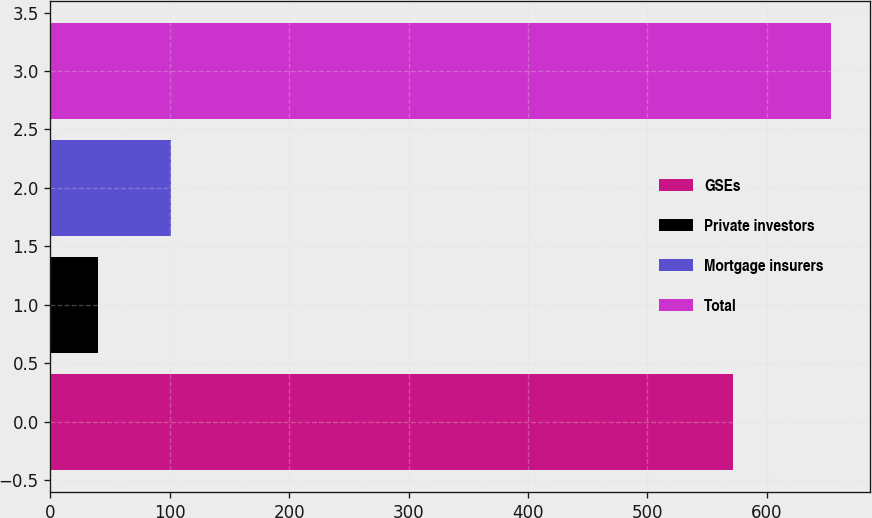<chart> <loc_0><loc_0><loc_500><loc_500><bar_chart><fcel>GSEs<fcel>Private investors<fcel>Mortgage insurers<fcel>Total<nl><fcel>572<fcel>40<fcel>101.4<fcel>654<nl></chart> 